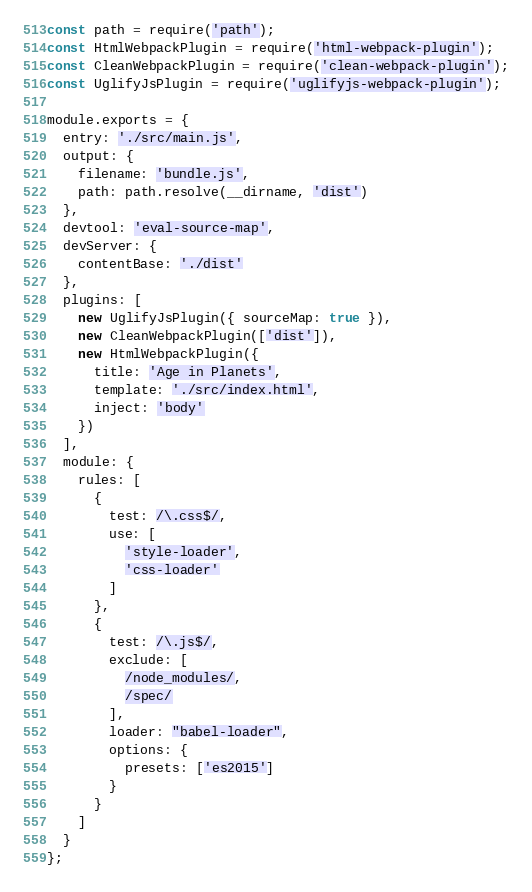Convert code to text. <code><loc_0><loc_0><loc_500><loc_500><_JavaScript_>const path = require('path');
const HtmlWebpackPlugin = require('html-webpack-plugin');
const CleanWebpackPlugin = require('clean-webpack-plugin');
const UglifyJsPlugin = require('uglifyjs-webpack-plugin');

module.exports = {
  entry: './src/main.js',
  output: {
    filename: 'bundle.js',
    path: path.resolve(__dirname, 'dist')
  },
  devtool: 'eval-source-map',
  devServer: {
    contentBase: './dist'
  },
  plugins: [
    new UglifyJsPlugin({ sourceMap: true }),
    new CleanWebpackPlugin(['dist']),
    new HtmlWebpackPlugin({
      title: 'Age in Planets',
      template: './src/index.html',
      inject: 'body'
    })
  ],
  module: {
    rules: [
      {
        test: /\.css$/,
        use: [
          'style-loader',
          'css-loader'
        ]
      },
      {
        test: /\.js$/,
        exclude: [
          /node_modules/,
          /spec/
        ],
        loader: "babel-loader",
        options: {
          presets: ['es2015']
        }
      }
    ]
  }
};
</code> 